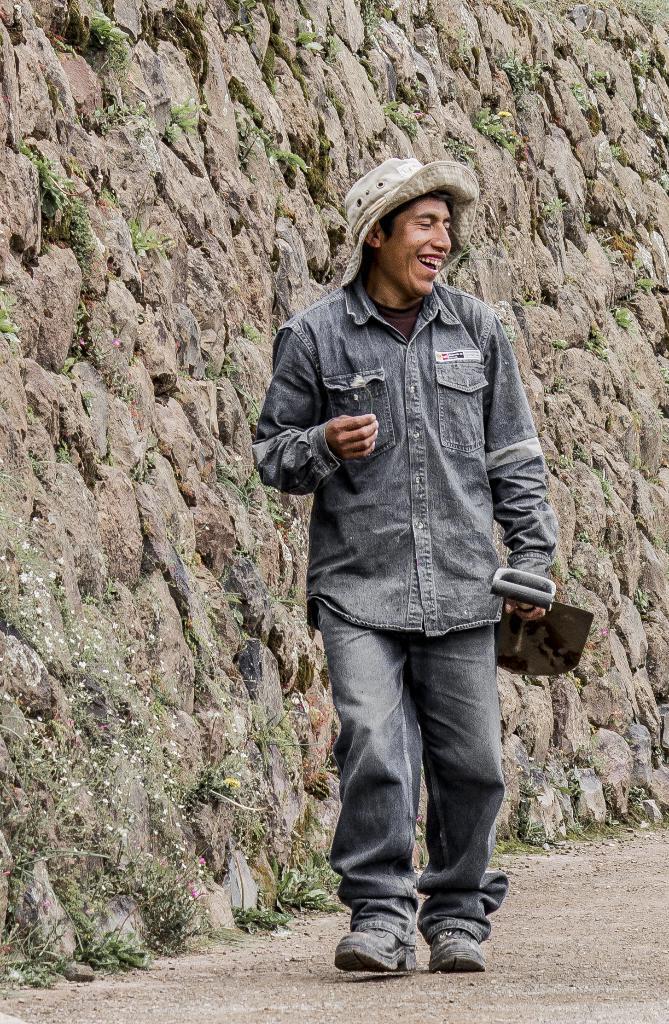How would you summarize this image in a sentence or two? In this image we can see a person wearing a hat, he is holding a shovel, and he is walking, beside to him we can see the rock wall, and the grass. 